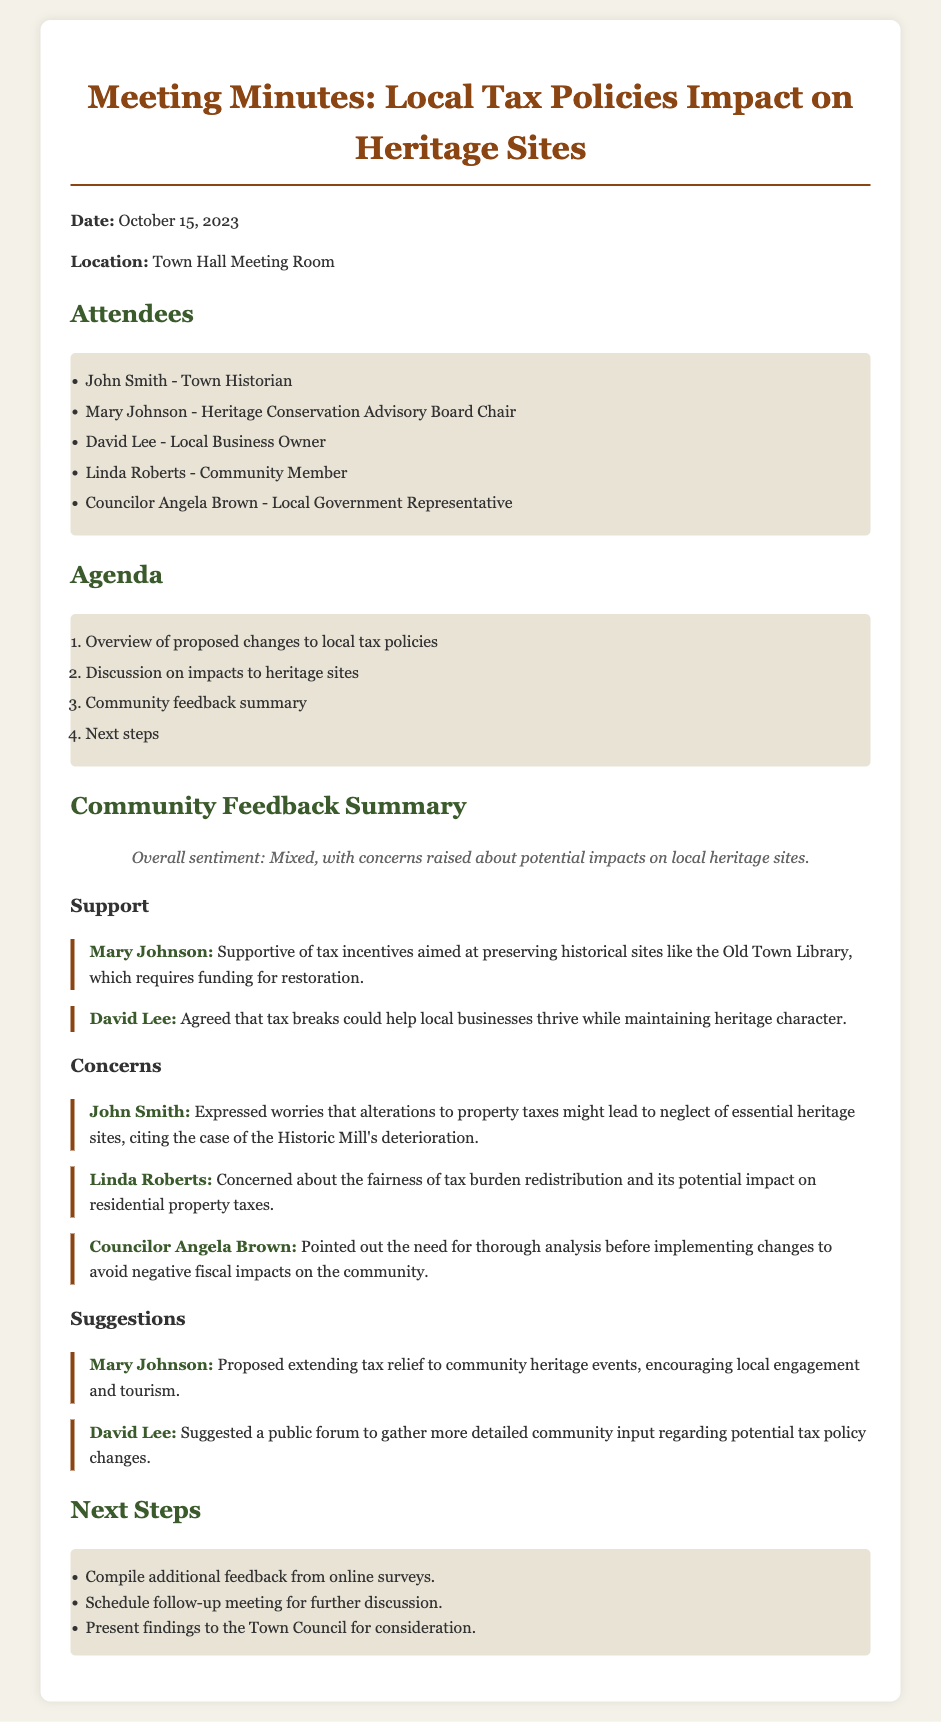What is the date of the meeting? The date of the meeting is stated at the beginning of the document.
Answer: October 15, 2023 Who is the Town Historian present at the meeting? The document lists attendees and identifies John Smith as the Town Historian.
Answer: John Smith What is the overall sentiment of the community feedback? The sentiment is summarized in a specific statement within the feedback section.
Answer: Mixed Which heritage site did Mary Johnson specifically mention? The name of the heritage site is provided in Mary Johnson's supportive comment.
Answer: Old Town Library What concern did John Smith express regarding tax changes? The document quotes John Smith’s concern about specific effects of tax changes on heritage sites.
Answer: Neglect of essential heritage sites What suggestion did David Lee propose for community input? A specific suggestion made by David Lee is noted in the suggestions section.
Answer: A public forum What specific step is mentioned for the next actions? The document outlines future actions to be taken after the meeting.
Answer: Compile additional feedback from online surveys Who is the chair of the Heritage Conservation Advisory Board? The attendees section names the chair of this board.
Answer: Mary Johnson 